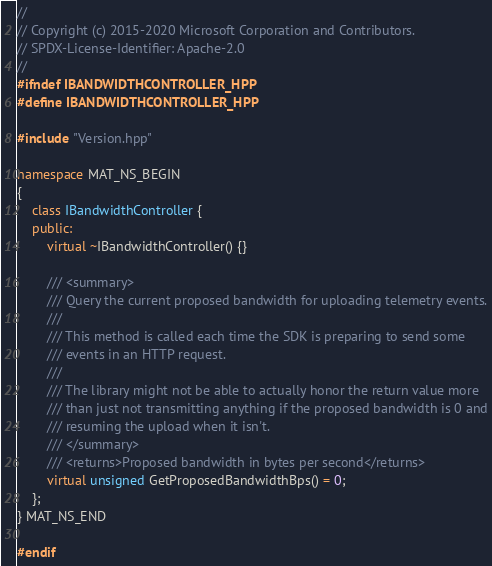<code> <loc_0><loc_0><loc_500><loc_500><_C++_>//
// Copyright (c) 2015-2020 Microsoft Corporation and Contributors.
// SPDX-License-Identifier: Apache-2.0
//
#ifndef IBANDWIDTHCONTROLLER_HPP
#define IBANDWIDTHCONTROLLER_HPP

#include "Version.hpp"

namespace MAT_NS_BEGIN
{
    class IBandwidthController {
    public:
        virtual ~IBandwidthController() {}

        /// <summary>
        /// Query the current proposed bandwidth for uploading telemetry events.
        ///
        /// This method is called each time the SDK is preparing to send some
        /// events in an HTTP request.
        ///
        /// The library might not be able to actually honor the return value more
        /// than just not transmitting anything if the proposed bandwidth is 0 and
        /// resuming the upload when it isn't.
        /// </summary>
        /// <returns>Proposed bandwidth in bytes per second</returns>
        virtual unsigned GetProposedBandwidthBps() = 0;
    };
} MAT_NS_END

#endif

</code> 